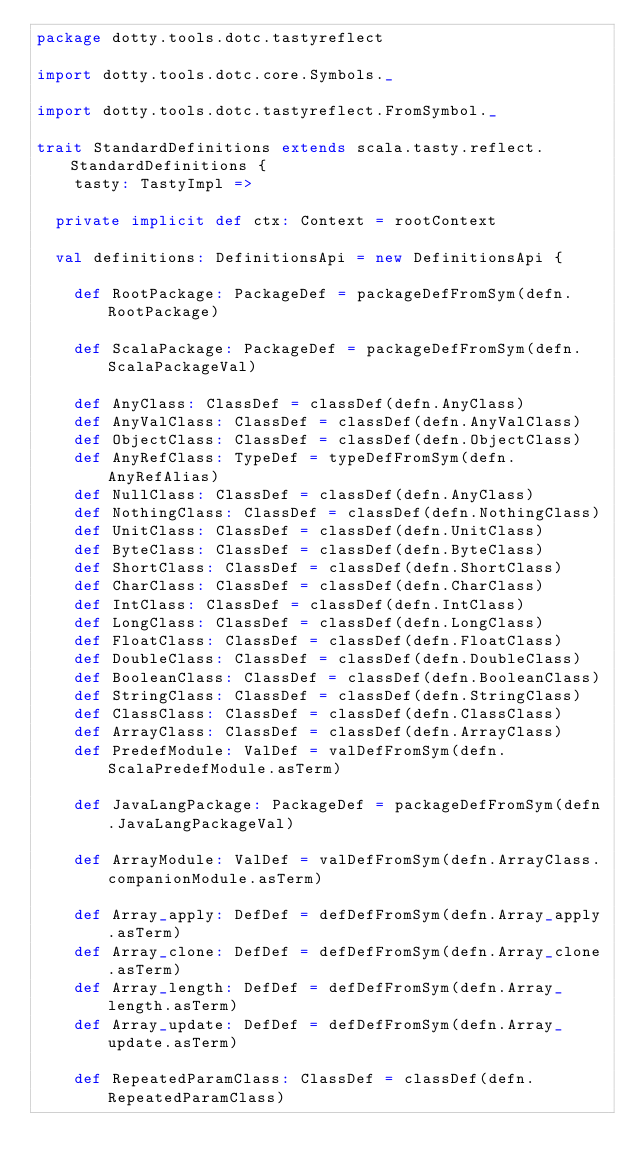<code> <loc_0><loc_0><loc_500><loc_500><_Scala_>package dotty.tools.dotc.tastyreflect

import dotty.tools.dotc.core.Symbols._

import dotty.tools.dotc.tastyreflect.FromSymbol._

trait StandardDefinitions extends scala.tasty.reflect.StandardDefinitions {
    tasty: TastyImpl =>

  private implicit def ctx: Context = rootContext

  val definitions: DefinitionsApi = new DefinitionsApi {

    def RootPackage: PackageDef = packageDefFromSym(defn.RootPackage)

    def ScalaPackage: PackageDef = packageDefFromSym(defn.ScalaPackageVal)

    def AnyClass: ClassDef = classDef(defn.AnyClass)
    def AnyValClass: ClassDef = classDef(defn.AnyValClass)
    def ObjectClass: ClassDef = classDef(defn.ObjectClass)
    def AnyRefClass: TypeDef = typeDefFromSym(defn.AnyRefAlias)
    def NullClass: ClassDef = classDef(defn.AnyClass)
    def NothingClass: ClassDef = classDef(defn.NothingClass)
    def UnitClass: ClassDef = classDef(defn.UnitClass)
    def ByteClass: ClassDef = classDef(defn.ByteClass)
    def ShortClass: ClassDef = classDef(defn.ShortClass)
    def CharClass: ClassDef = classDef(defn.CharClass)
    def IntClass: ClassDef = classDef(defn.IntClass)
    def LongClass: ClassDef = classDef(defn.LongClass)
    def FloatClass: ClassDef = classDef(defn.FloatClass)
    def DoubleClass: ClassDef = classDef(defn.DoubleClass)
    def BooleanClass: ClassDef = classDef(defn.BooleanClass)
    def StringClass: ClassDef = classDef(defn.StringClass)
    def ClassClass: ClassDef = classDef(defn.ClassClass)
    def ArrayClass: ClassDef = classDef(defn.ArrayClass)
    def PredefModule: ValDef = valDefFromSym(defn.ScalaPredefModule.asTerm)

    def JavaLangPackage: PackageDef = packageDefFromSym(defn.JavaLangPackageVal)

    def ArrayModule: ValDef = valDefFromSym(defn.ArrayClass.companionModule.asTerm)

    def Array_apply: DefDef = defDefFromSym(defn.Array_apply.asTerm)
    def Array_clone: DefDef = defDefFromSym(defn.Array_clone.asTerm)
    def Array_length: DefDef = defDefFromSym(defn.Array_length.asTerm)
    def Array_update: DefDef = defDefFromSym(defn.Array_update.asTerm)

    def RepeatedParamClass: ClassDef = classDef(defn.RepeatedParamClass)
</code> 